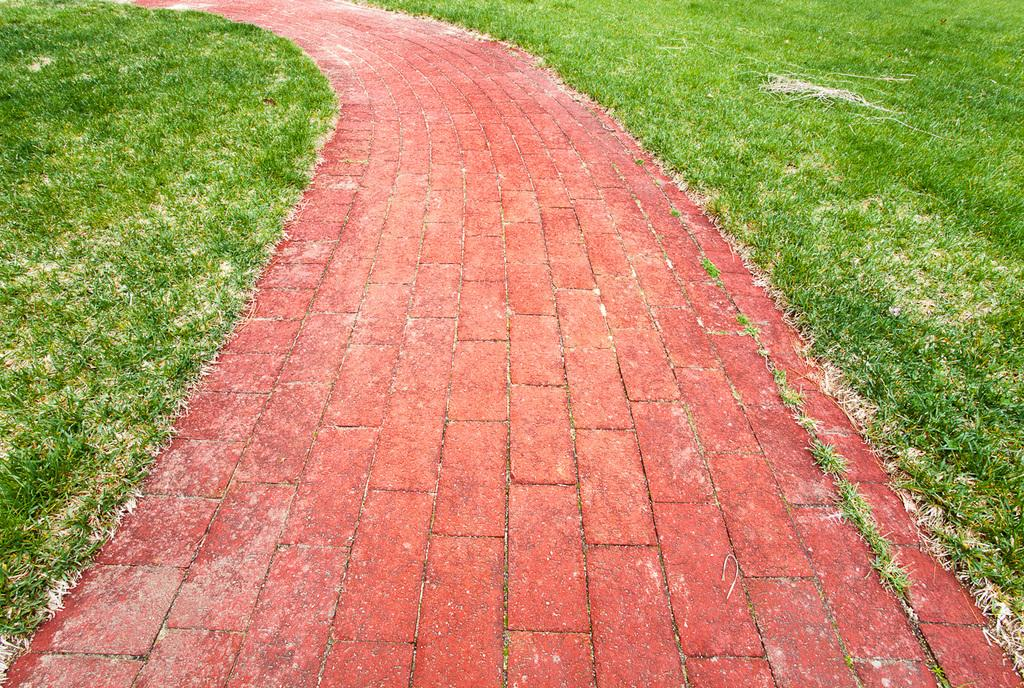What type of vegetation is present in the image? There is grass in the image. What can be seen besides the grass in the image? There is a path in the image. What type of sack is being carried by the crook in the image? There is no crook or sack present in the image; it only features grass and a path. 